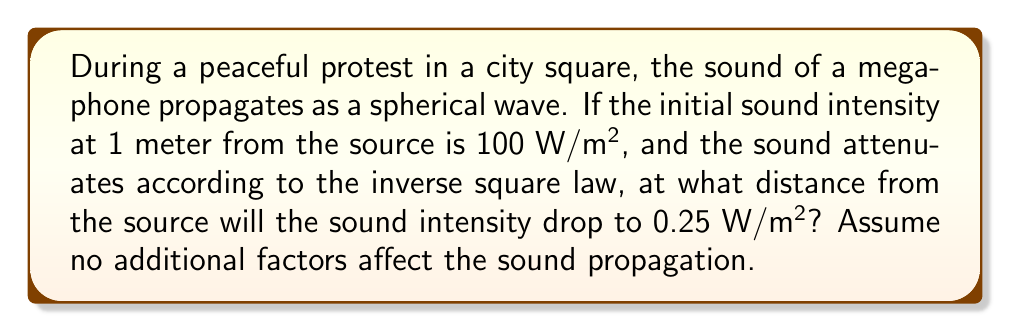Show me your answer to this math problem. Let's approach this step-by-step:

1) The inverse square law for sound intensity states that:

   $$I_2 = I_1 \left(\frac{r_1}{r_2}\right)^2$$

   where $I_1$ and $I_2$ are the intensities at distances $r_1$ and $r_2$ respectively.

2) We're given:
   $I_1 = 100$ W/m² at $r_1 = 1$ m
   $I_2 = 0.25$ W/m² at $r_2 = ?$ m

3) Substituting these values into the equation:

   $$0.25 = 100 \left(\frac{1}{r_2}\right)^2$$

4) Simplify:
   $$0.25 = \frac{100}{r_2^2}$$

5) Multiply both sides by $r_2^2$:
   $$0.25r_2^2 = 100$$

6) Divide both sides by 0.25:
   $$r_2^2 = 400$$

7) Take the square root of both sides:
   $$r_2 = \sqrt{400} = 20$$

Therefore, the sound intensity will drop to 0.25 W/m² at a distance of 20 meters from the source.
Answer: 20 meters 